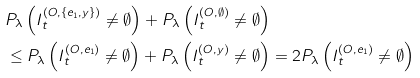<formula> <loc_0><loc_0><loc_500><loc_500>& P _ { \lambda } \left ( I _ { t } ^ { ( O , \{ e _ { 1 } , y \} ) } \neq \emptyset \right ) + P _ { \lambda } \left ( I _ { t } ^ { ( O , \emptyset ) } \neq \emptyset \right ) \\ & \leq P _ { \lambda } \left ( I _ { t } ^ { ( O , e _ { 1 } ) } \neq \emptyset \right ) + P _ { \lambda } \left ( I _ { t } ^ { ( O , y ) } \neq \emptyset \right ) = 2 P _ { \lambda } \left ( I _ { t } ^ { ( O , e _ { 1 } ) } \neq \emptyset \right )</formula> 